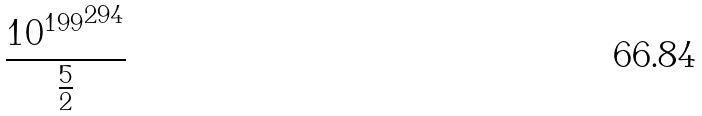Convert formula to latex. <formula><loc_0><loc_0><loc_500><loc_500>\frac { { 1 0 ^ { 1 9 9 } } ^ { 2 9 4 } } { \frac { 5 } { 2 } }</formula> 